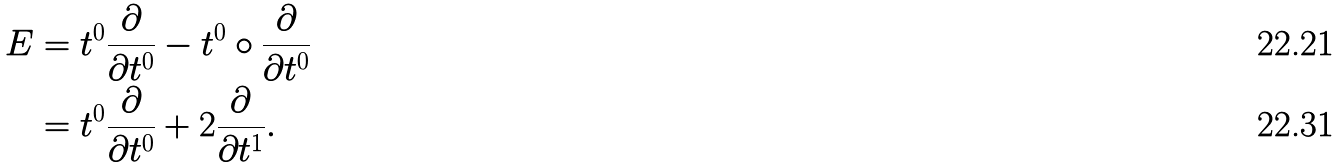Convert formula to latex. <formula><loc_0><loc_0><loc_500><loc_500>E & = t ^ { 0 } \frac { \partial } { \partial t ^ { 0 } } - t ^ { 0 } \circ \frac { \partial } { \partial t ^ { 0 } } \\ & = t ^ { 0 } \frac { \partial } { \partial t ^ { 0 } } + 2 \frac { \partial } { \partial t ^ { 1 } } .</formula> 